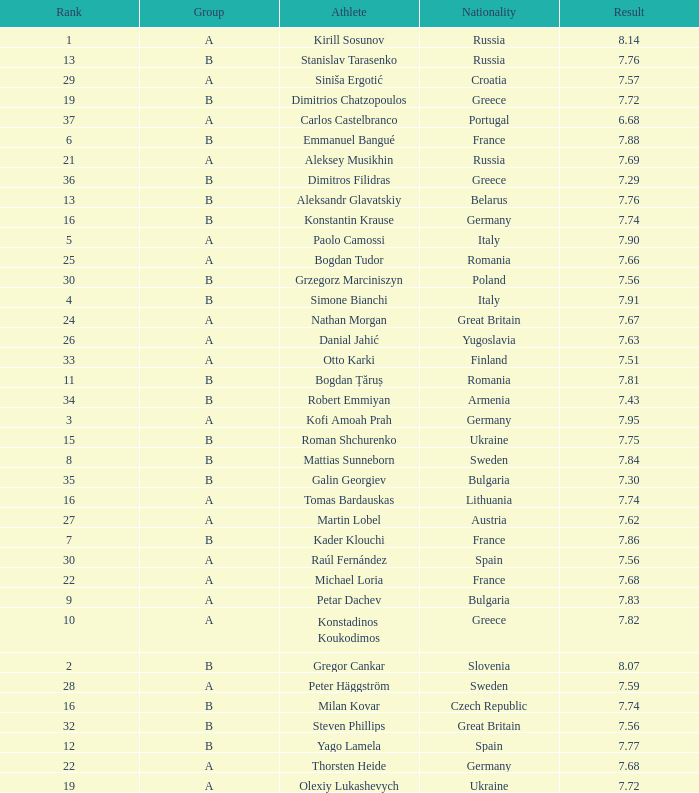Which athlete's rank is more than 15 when the result is less than 7.68, the group is b, and the nationality listed is Great Britain? Steven Phillips. 